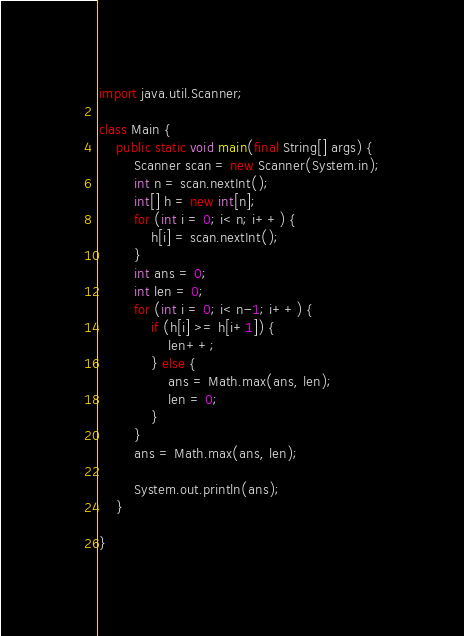Convert code to text. <code><loc_0><loc_0><loc_500><loc_500><_Java_>import java.util.Scanner;

class Main {
    public static void main(final String[] args) {
        Scanner scan = new Scanner(System.in);
        int n = scan.nextInt();
        int[] h = new int[n];
        for (int i = 0; i< n; i++) {
            h[i] = scan.nextInt();
        }
        int ans = 0;
        int len = 0;
        for (int i = 0; i< n-1; i++) {
            if (h[i] >= h[i+1]) {
                len++;
            } else {
                ans = Math.max(ans, len);
                len = 0;
            }
        }
        ans = Math.max(ans, len);

        System.out.println(ans);
    }

}</code> 